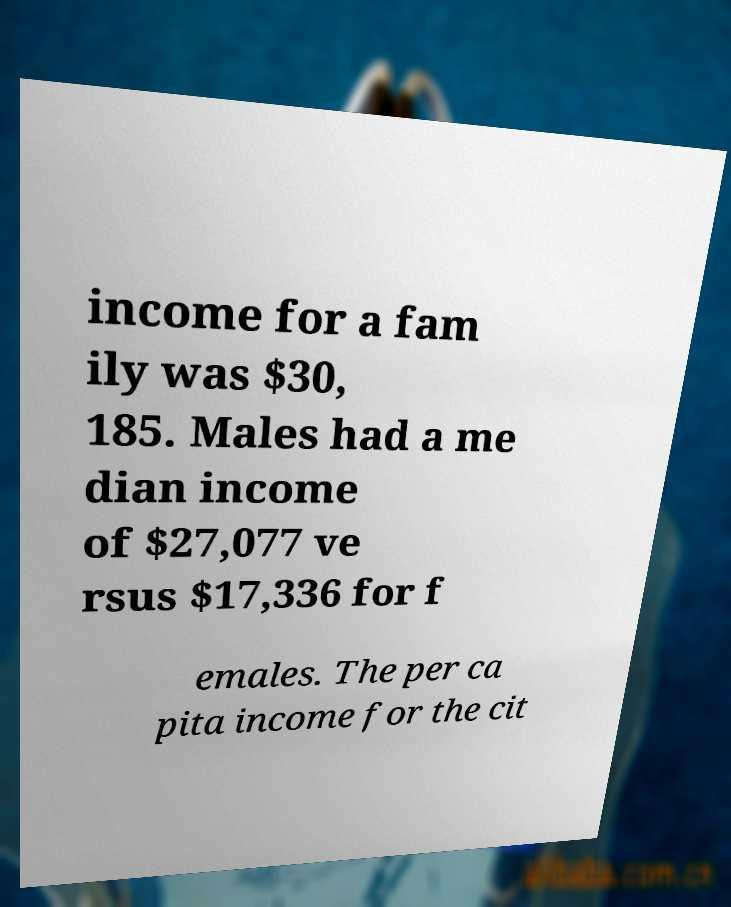Please identify and transcribe the text found in this image. income for a fam ily was $30, 185. Males had a me dian income of $27,077 ve rsus $17,336 for f emales. The per ca pita income for the cit 